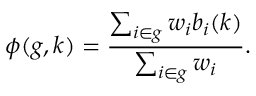Convert formula to latex. <formula><loc_0><loc_0><loc_500><loc_500>\phi ( g , k ) = \frac { \sum _ { i \in g } w _ { i } b _ { i } ( k ) } { \sum _ { i \in g } w _ { i } } .</formula> 